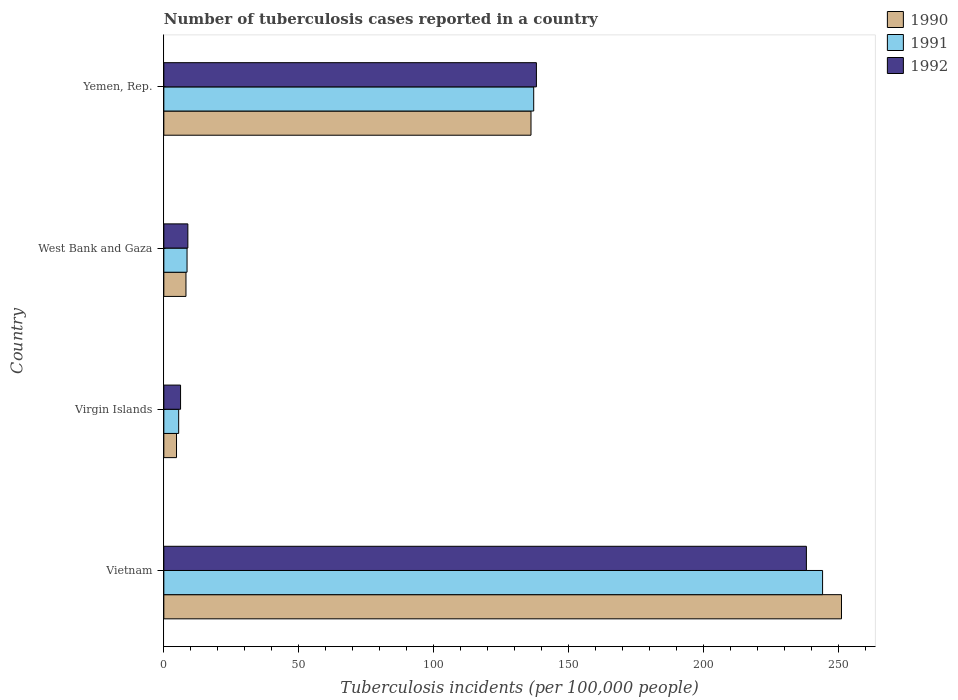What is the label of the 1st group of bars from the top?
Keep it short and to the point. Yemen, Rep. In how many cases, is the number of bars for a given country not equal to the number of legend labels?
Offer a terse response. 0. What is the number of tuberculosis cases reported in in 1991 in West Bank and Gaza?
Your answer should be compact. 8.6. Across all countries, what is the maximum number of tuberculosis cases reported in in 1990?
Make the answer very short. 251. In which country was the number of tuberculosis cases reported in in 1990 maximum?
Your answer should be very brief. Vietnam. In which country was the number of tuberculosis cases reported in in 1991 minimum?
Keep it short and to the point. Virgin Islands. What is the total number of tuberculosis cases reported in in 1992 in the graph?
Your response must be concise. 391.1. What is the difference between the number of tuberculosis cases reported in in 1992 in West Bank and Gaza and that in Yemen, Rep.?
Your response must be concise. -129.1. What is the difference between the number of tuberculosis cases reported in in 1991 in Virgin Islands and the number of tuberculosis cases reported in in 1992 in West Bank and Gaza?
Give a very brief answer. -3.4. What is the average number of tuberculosis cases reported in in 1991 per country?
Provide a short and direct response. 98.78. What is the difference between the number of tuberculosis cases reported in in 1991 and number of tuberculosis cases reported in in 1990 in Virgin Islands?
Offer a terse response. 0.8. What is the ratio of the number of tuberculosis cases reported in in 1991 in Vietnam to that in West Bank and Gaza?
Provide a short and direct response. 28.37. Is the difference between the number of tuberculosis cases reported in in 1991 in Vietnam and Virgin Islands greater than the difference between the number of tuberculosis cases reported in in 1990 in Vietnam and Virgin Islands?
Provide a succinct answer. No. What is the difference between the highest and the second highest number of tuberculosis cases reported in in 1992?
Give a very brief answer. 100. What is the difference between the highest and the lowest number of tuberculosis cases reported in in 1992?
Make the answer very short. 231.8. Is the sum of the number of tuberculosis cases reported in in 1991 in Virgin Islands and Yemen, Rep. greater than the maximum number of tuberculosis cases reported in in 1992 across all countries?
Give a very brief answer. No. What does the 1st bar from the top in West Bank and Gaza represents?
Ensure brevity in your answer.  1992. Is it the case that in every country, the sum of the number of tuberculosis cases reported in in 1992 and number of tuberculosis cases reported in in 1990 is greater than the number of tuberculosis cases reported in in 1991?
Offer a very short reply. Yes. How many bars are there?
Provide a short and direct response. 12. Are all the bars in the graph horizontal?
Your response must be concise. Yes. How many countries are there in the graph?
Your answer should be compact. 4. What is the difference between two consecutive major ticks on the X-axis?
Your response must be concise. 50. Are the values on the major ticks of X-axis written in scientific E-notation?
Provide a short and direct response. No. Does the graph contain grids?
Offer a very short reply. No. Where does the legend appear in the graph?
Keep it short and to the point. Top right. How are the legend labels stacked?
Ensure brevity in your answer.  Vertical. What is the title of the graph?
Your response must be concise. Number of tuberculosis cases reported in a country. What is the label or title of the X-axis?
Your answer should be compact. Tuberculosis incidents (per 100,0 people). What is the label or title of the Y-axis?
Keep it short and to the point. Country. What is the Tuberculosis incidents (per 100,000 people) of 1990 in Vietnam?
Your answer should be very brief. 251. What is the Tuberculosis incidents (per 100,000 people) in 1991 in Vietnam?
Offer a very short reply. 244. What is the Tuberculosis incidents (per 100,000 people) in 1992 in Vietnam?
Make the answer very short. 238. What is the Tuberculosis incidents (per 100,000 people) in 1992 in Virgin Islands?
Provide a succinct answer. 6.2. What is the Tuberculosis incidents (per 100,000 people) in 1990 in West Bank and Gaza?
Offer a terse response. 8.2. What is the Tuberculosis incidents (per 100,000 people) in 1991 in West Bank and Gaza?
Provide a succinct answer. 8.6. What is the Tuberculosis incidents (per 100,000 people) in 1990 in Yemen, Rep.?
Your response must be concise. 136. What is the Tuberculosis incidents (per 100,000 people) in 1991 in Yemen, Rep.?
Provide a short and direct response. 137. What is the Tuberculosis incidents (per 100,000 people) in 1992 in Yemen, Rep.?
Your answer should be compact. 138. Across all countries, what is the maximum Tuberculosis incidents (per 100,000 people) of 1990?
Your answer should be compact. 251. Across all countries, what is the maximum Tuberculosis incidents (per 100,000 people) of 1991?
Give a very brief answer. 244. Across all countries, what is the maximum Tuberculosis incidents (per 100,000 people) in 1992?
Give a very brief answer. 238. Across all countries, what is the minimum Tuberculosis incidents (per 100,000 people) in 1992?
Ensure brevity in your answer.  6.2. What is the total Tuberculosis incidents (per 100,000 people) in 1990 in the graph?
Give a very brief answer. 399.9. What is the total Tuberculosis incidents (per 100,000 people) of 1991 in the graph?
Offer a terse response. 395.1. What is the total Tuberculosis incidents (per 100,000 people) in 1992 in the graph?
Provide a short and direct response. 391.1. What is the difference between the Tuberculosis incidents (per 100,000 people) of 1990 in Vietnam and that in Virgin Islands?
Make the answer very short. 246.3. What is the difference between the Tuberculosis incidents (per 100,000 people) of 1991 in Vietnam and that in Virgin Islands?
Give a very brief answer. 238.5. What is the difference between the Tuberculosis incidents (per 100,000 people) in 1992 in Vietnam and that in Virgin Islands?
Your answer should be compact. 231.8. What is the difference between the Tuberculosis incidents (per 100,000 people) of 1990 in Vietnam and that in West Bank and Gaza?
Your answer should be compact. 242.8. What is the difference between the Tuberculosis incidents (per 100,000 people) of 1991 in Vietnam and that in West Bank and Gaza?
Offer a very short reply. 235.4. What is the difference between the Tuberculosis incidents (per 100,000 people) in 1992 in Vietnam and that in West Bank and Gaza?
Offer a very short reply. 229.1. What is the difference between the Tuberculosis incidents (per 100,000 people) in 1990 in Vietnam and that in Yemen, Rep.?
Ensure brevity in your answer.  115. What is the difference between the Tuberculosis incidents (per 100,000 people) in 1991 in Vietnam and that in Yemen, Rep.?
Keep it short and to the point. 107. What is the difference between the Tuberculosis incidents (per 100,000 people) in 1992 in Vietnam and that in Yemen, Rep.?
Give a very brief answer. 100. What is the difference between the Tuberculosis incidents (per 100,000 people) of 1991 in Virgin Islands and that in West Bank and Gaza?
Offer a terse response. -3.1. What is the difference between the Tuberculosis incidents (per 100,000 people) of 1992 in Virgin Islands and that in West Bank and Gaza?
Offer a terse response. -2.7. What is the difference between the Tuberculosis incidents (per 100,000 people) in 1990 in Virgin Islands and that in Yemen, Rep.?
Your response must be concise. -131.3. What is the difference between the Tuberculosis incidents (per 100,000 people) in 1991 in Virgin Islands and that in Yemen, Rep.?
Ensure brevity in your answer.  -131.5. What is the difference between the Tuberculosis incidents (per 100,000 people) in 1992 in Virgin Islands and that in Yemen, Rep.?
Provide a short and direct response. -131.8. What is the difference between the Tuberculosis incidents (per 100,000 people) in 1990 in West Bank and Gaza and that in Yemen, Rep.?
Provide a succinct answer. -127.8. What is the difference between the Tuberculosis incidents (per 100,000 people) in 1991 in West Bank and Gaza and that in Yemen, Rep.?
Offer a very short reply. -128.4. What is the difference between the Tuberculosis incidents (per 100,000 people) of 1992 in West Bank and Gaza and that in Yemen, Rep.?
Make the answer very short. -129.1. What is the difference between the Tuberculosis incidents (per 100,000 people) of 1990 in Vietnam and the Tuberculosis incidents (per 100,000 people) of 1991 in Virgin Islands?
Ensure brevity in your answer.  245.5. What is the difference between the Tuberculosis incidents (per 100,000 people) of 1990 in Vietnam and the Tuberculosis incidents (per 100,000 people) of 1992 in Virgin Islands?
Your response must be concise. 244.8. What is the difference between the Tuberculosis incidents (per 100,000 people) in 1991 in Vietnam and the Tuberculosis incidents (per 100,000 people) in 1992 in Virgin Islands?
Offer a terse response. 237.8. What is the difference between the Tuberculosis incidents (per 100,000 people) of 1990 in Vietnam and the Tuberculosis incidents (per 100,000 people) of 1991 in West Bank and Gaza?
Keep it short and to the point. 242.4. What is the difference between the Tuberculosis incidents (per 100,000 people) of 1990 in Vietnam and the Tuberculosis incidents (per 100,000 people) of 1992 in West Bank and Gaza?
Keep it short and to the point. 242.1. What is the difference between the Tuberculosis incidents (per 100,000 people) in 1991 in Vietnam and the Tuberculosis incidents (per 100,000 people) in 1992 in West Bank and Gaza?
Provide a short and direct response. 235.1. What is the difference between the Tuberculosis incidents (per 100,000 people) in 1990 in Vietnam and the Tuberculosis incidents (per 100,000 people) in 1991 in Yemen, Rep.?
Provide a short and direct response. 114. What is the difference between the Tuberculosis incidents (per 100,000 people) of 1990 in Vietnam and the Tuberculosis incidents (per 100,000 people) of 1992 in Yemen, Rep.?
Your response must be concise. 113. What is the difference between the Tuberculosis incidents (per 100,000 people) in 1991 in Vietnam and the Tuberculosis incidents (per 100,000 people) in 1992 in Yemen, Rep.?
Keep it short and to the point. 106. What is the difference between the Tuberculosis incidents (per 100,000 people) in 1990 in Virgin Islands and the Tuberculosis incidents (per 100,000 people) in 1991 in West Bank and Gaza?
Provide a succinct answer. -3.9. What is the difference between the Tuberculosis incidents (per 100,000 people) of 1991 in Virgin Islands and the Tuberculosis incidents (per 100,000 people) of 1992 in West Bank and Gaza?
Make the answer very short. -3.4. What is the difference between the Tuberculosis incidents (per 100,000 people) in 1990 in Virgin Islands and the Tuberculosis incidents (per 100,000 people) in 1991 in Yemen, Rep.?
Provide a succinct answer. -132.3. What is the difference between the Tuberculosis incidents (per 100,000 people) in 1990 in Virgin Islands and the Tuberculosis incidents (per 100,000 people) in 1992 in Yemen, Rep.?
Give a very brief answer. -133.3. What is the difference between the Tuberculosis incidents (per 100,000 people) of 1991 in Virgin Islands and the Tuberculosis incidents (per 100,000 people) of 1992 in Yemen, Rep.?
Make the answer very short. -132.5. What is the difference between the Tuberculosis incidents (per 100,000 people) in 1990 in West Bank and Gaza and the Tuberculosis incidents (per 100,000 people) in 1991 in Yemen, Rep.?
Keep it short and to the point. -128.8. What is the difference between the Tuberculosis incidents (per 100,000 people) in 1990 in West Bank and Gaza and the Tuberculosis incidents (per 100,000 people) in 1992 in Yemen, Rep.?
Your answer should be very brief. -129.8. What is the difference between the Tuberculosis incidents (per 100,000 people) in 1991 in West Bank and Gaza and the Tuberculosis incidents (per 100,000 people) in 1992 in Yemen, Rep.?
Make the answer very short. -129.4. What is the average Tuberculosis incidents (per 100,000 people) of 1990 per country?
Offer a very short reply. 99.97. What is the average Tuberculosis incidents (per 100,000 people) in 1991 per country?
Provide a short and direct response. 98.78. What is the average Tuberculosis incidents (per 100,000 people) of 1992 per country?
Make the answer very short. 97.78. What is the difference between the Tuberculosis incidents (per 100,000 people) of 1990 and Tuberculosis incidents (per 100,000 people) of 1992 in Vietnam?
Provide a succinct answer. 13. What is the difference between the Tuberculosis incidents (per 100,000 people) of 1991 and Tuberculosis incidents (per 100,000 people) of 1992 in Vietnam?
Offer a terse response. 6. What is the difference between the Tuberculosis incidents (per 100,000 people) in 1990 and Tuberculosis incidents (per 100,000 people) in 1991 in Virgin Islands?
Offer a terse response. -0.8. What is the difference between the Tuberculosis incidents (per 100,000 people) in 1990 and Tuberculosis incidents (per 100,000 people) in 1992 in Virgin Islands?
Make the answer very short. -1.5. What is the difference between the Tuberculosis incidents (per 100,000 people) in 1990 and Tuberculosis incidents (per 100,000 people) in 1991 in West Bank and Gaza?
Your answer should be compact. -0.4. What is the difference between the Tuberculosis incidents (per 100,000 people) of 1990 and Tuberculosis incidents (per 100,000 people) of 1992 in West Bank and Gaza?
Offer a terse response. -0.7. What is the difference between the Tuberculosis incidents (per 100,000 people) in 1991 and Tuberculosis incidents (per 100,000 people) in 1992 in West Bank and Gaza?
Provide a succinct answer. -0.3. What is the ratio of the Tuberculosis incidents (per 100,000 people) of 1990 in Vietnam to that in Virgin Islands?
Offer a terse response. 53.4. What is the ratio of the Tuberculosis incidents (per 100,000 people) of 1991 in Vietnam to that in Virgin Islands?
Ensure brevity in your answer.  44.36. What is the ratio of the Tuberculosis incidents (per 100,000 people) of 1992 in Vietnam to that in Virgin Islands?
Your answer should be very brief. 38.39. What is the ratio of the Tuberculosis incidents (per 100,000 people) of 1990 in Vietnam to that in West Bank and Gaza?
Offer a terse response. 30.61. What is the ratio of the Tuberculosis incidents (per 100,000 people) in 1991 in Vietnam to that in West Bank and Gaza?
Make the answer very short. 28.37. What is the ratio of the Tuberculosis incidents (per 100,000 people) in 1992 in Vietnam to that in West Bank and Gaza?
Your answer should be compact. 26.74. What is the ratio of the Tuberculosis incidents (per 100,000 people) in 1990 in Vietnam to that in Yemen, Rep.?
Your response must be concise. 1.85. What is the ratio of the Tuberculosis incidents (per 100,000 people) of 1991 in Vietnam to that in Yemen, Rep.?
Your answer should be very brief. 1.78. What is the ratio of the Tuberculosis incidents (per 100,000 people) in 1992 in Vietnam to that in Yemen, Rep.?
Offer a terse response. 1.72. What is the ratio of the Tuberculosis incidents (per 100,000 people) of 1990 in Virgin Islands to that in West Bank and Gaza?
Your answer should be very brief. 0.57. What is the ratio of the Tuberculosis incidents (per 100,000 people) in 1991 in Virgin Islands to that in West Bank and Gaza?
Offer a very short reply. 0.64. What is the ratio of the Tuberculosis incidents (per 100,000 people) in 1992 in Virgin Islands to that in West Bank and Gaza?
Offer a very short reply. 0.7. What is the ratio of the Tuberculosis incidents (per 100,000 people) in 1990 in Virgin Islands to that in Yemen, Rep.?
Your answer should be very brief. 0.03. What is the ratio of the Tuberculosis incidents (per 100,000 people) of 1991 in Virgin Islands to that in Yemen, Rep.?
Give a very brief answer. 0.04. What is the ratio of the Tuberculosis incidents (per 100,000 people) in 1992 in Virgin Islands to that in Yemen, Rep.?
Provide a short and direct response. 0.04. What is the ratio of the Tuberculosis incidents (per 100,000 people) of 1990 in West Bank and Gaza to that in Yemen, Rep.?
Your answer should be very brief. 0.06. What is the ratio of the Tuberculosis incidents (per 100,000 people) in 1991 in West Bank and Gaza to that in Yemen, Rep.?
Your answer should be very brief. 0.06. What is the ratio of the Tuberculosis incidents (per 100,000 people) in 1992 in West Bank and Gaza to that in Yemen, Rep.?
Make the answer very short. 0.06. What is the difference between the highest and the second highest Tuberculosis incidents (per 100,000 people) in 1990?
Give a very brief answer. 115. What is the difference between the highest and the second highest Tuberculosis incidents (per 100,000 people) in 1991?
Provide a short and direct response. 107. What is the difference between the highest and the second highest Tuberculosis incidents (per 100,000 people) of 1992?
Provide a short and direct response. 100. What is the difference between the highest and the lowest Tuberculosis incidents (per 100,000 people) of 1990?
Provide a short and direct response. 246.3. What is the difference between the highest and the lowest Tuberculosis incidents (per 100,000 people) in 1991?
Your answer should be very brief. 238.5. What is the difference between the highest and the lowest Tuberculosis incidents (per 100,000 people) of 1992?
Make the answer very short. 231.8. 